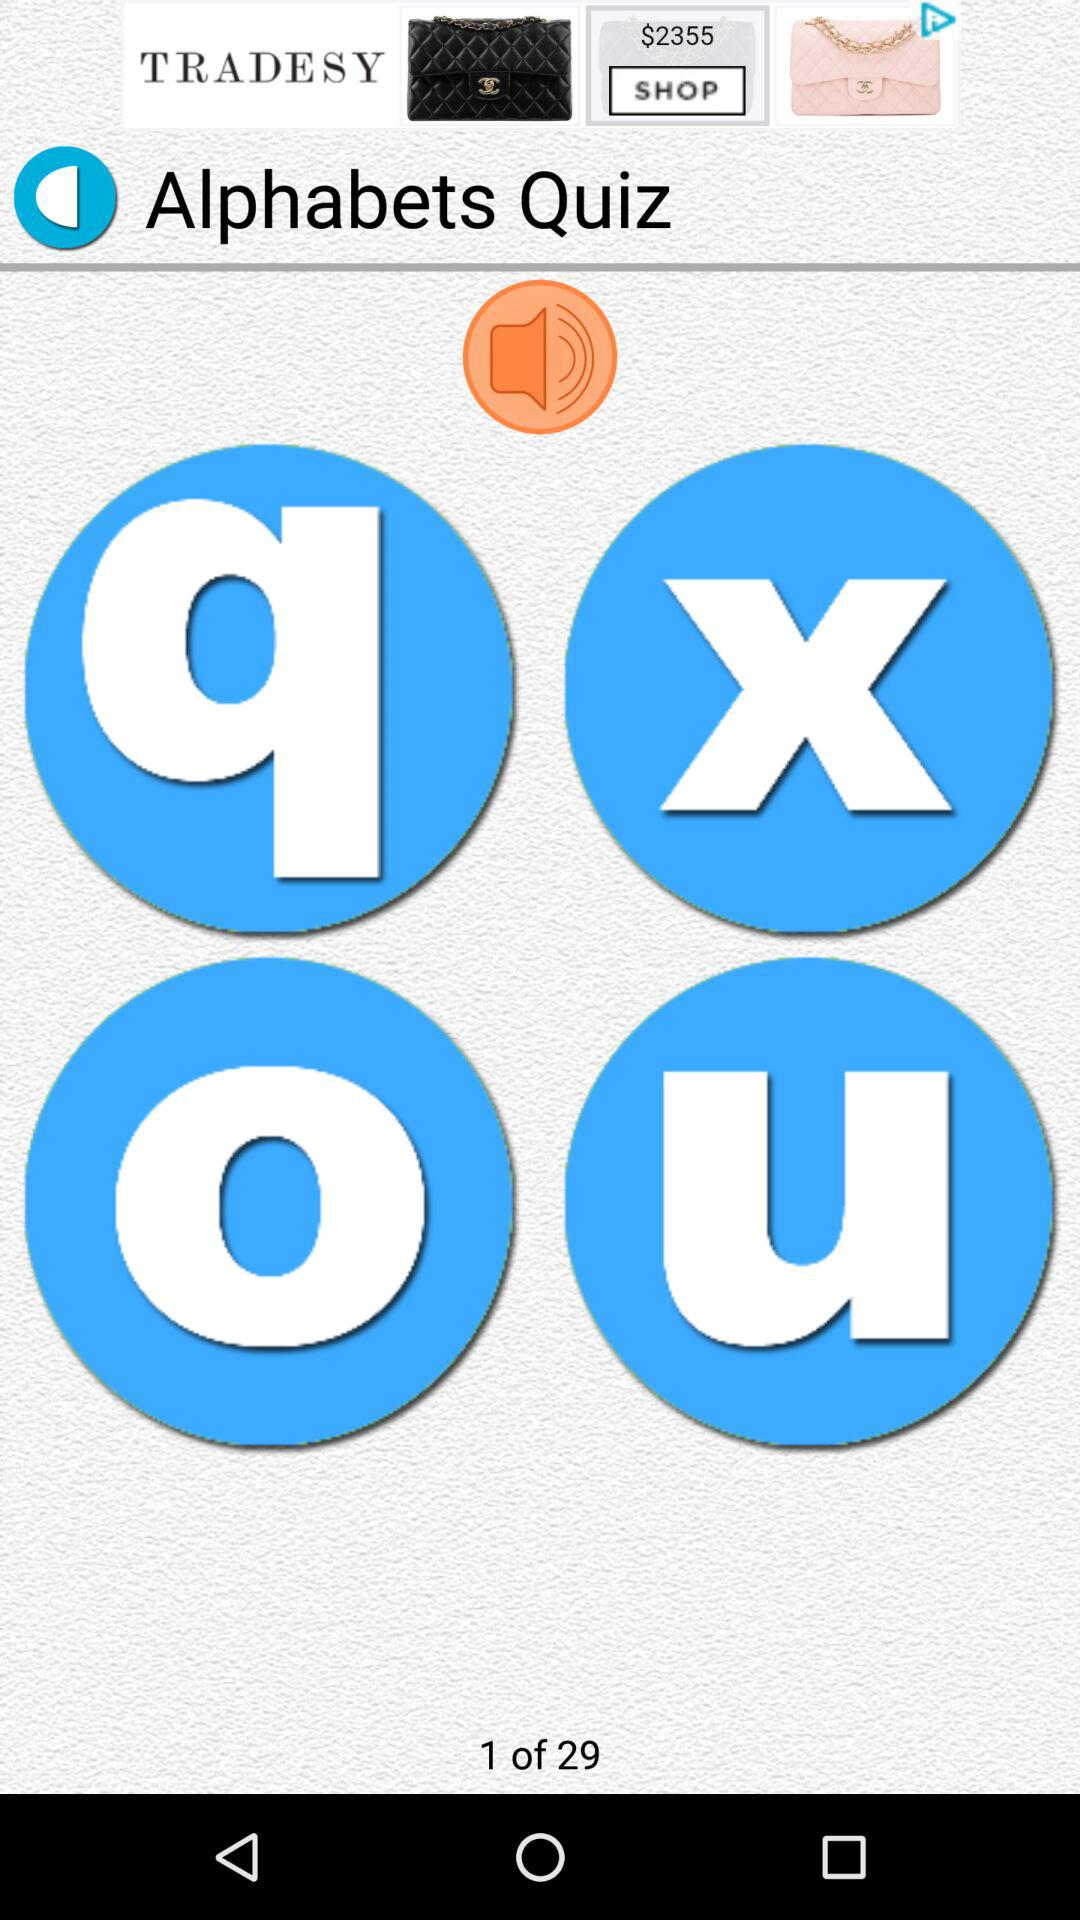At which question am I? You are at the first question. 